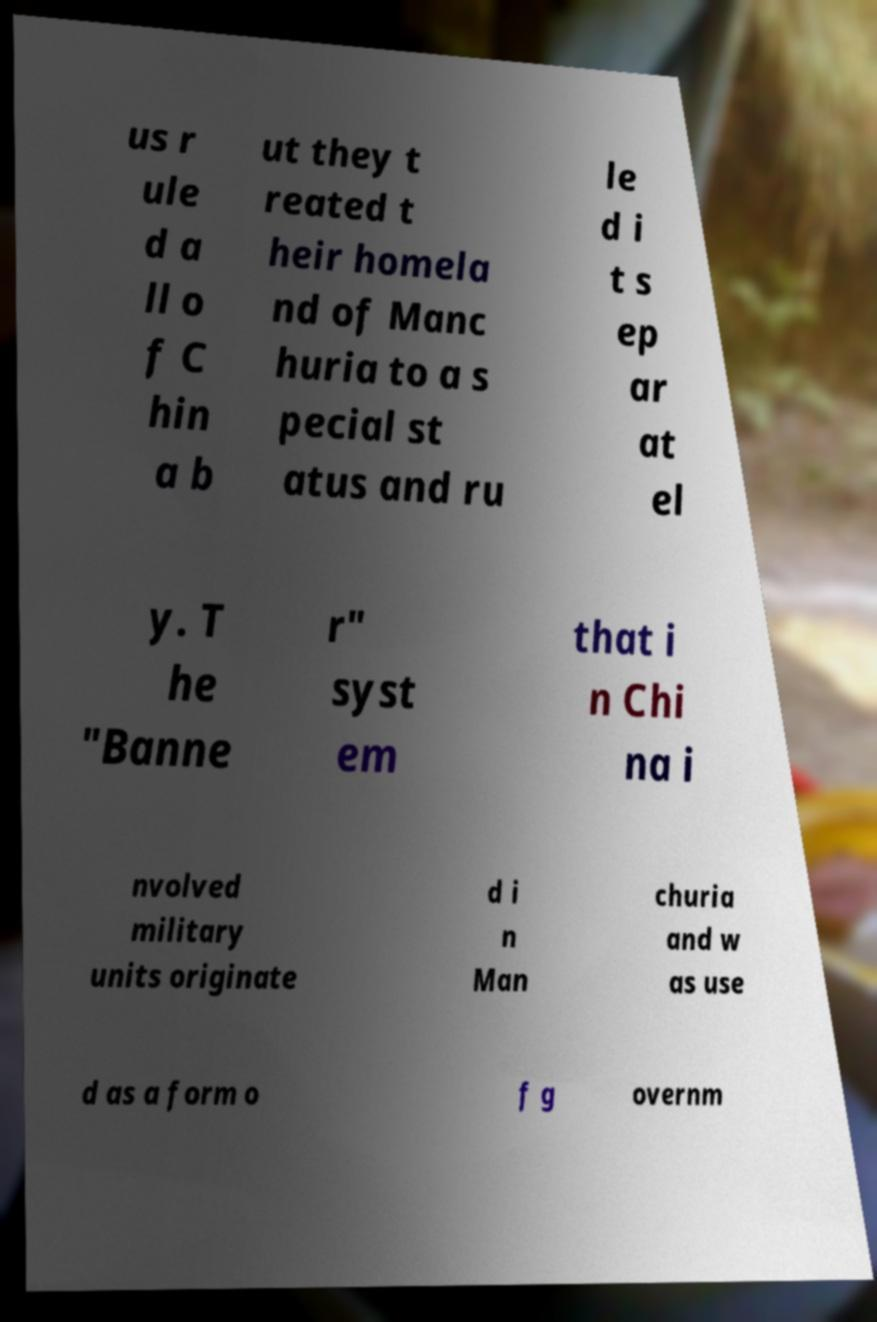I need the written content from this picture converted into text. Can you do that? us r ule d a ll o f C hin a b ut they t reated t heir homela nd of Manc huria to a s pecial st atus and ru le d i t s ep ar at el y. T he "Banne r" syst em that i n Chi na i nvolved military units originate d i n Man churia and w as use d as a form o f g overnm 